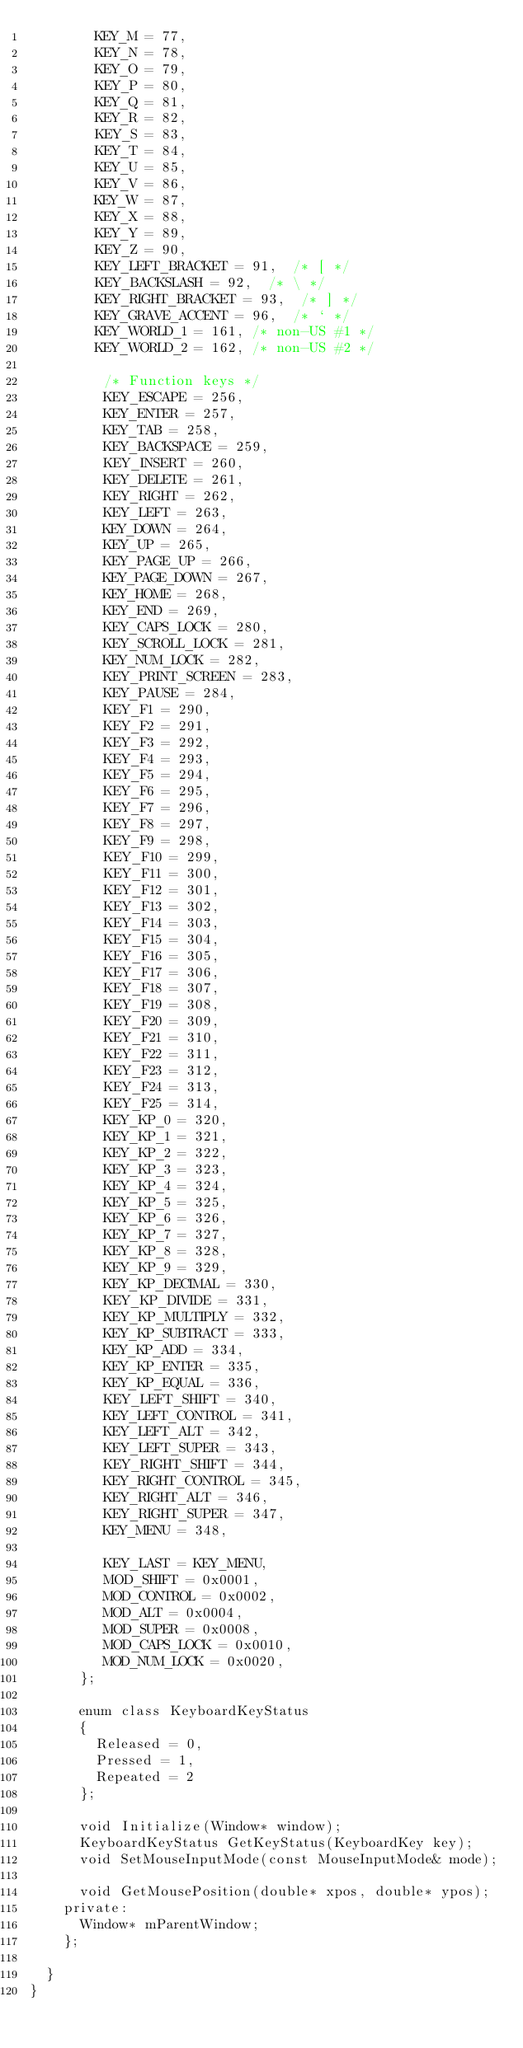<code> <loc_0><loc_0><loc_500><loc_500><_C_>				KEY_M = 77,
				KEY_N = 78,
				KEY_O = 79,
				KEY_P = 80,
				KEY_Q = 81,
				KEY_R = 82,
				KEY_S = 83,
				KEY_T = 84,
				KEY_U = 85,
				KEY_V = 86,
				KEY_W = 87,
				KEY_X = 88,
				KEY_Y = 89,
				KEY_Z = 90,
				KEY_LEFT_BRACKET = 91,  /* [ */
				KEY_BACKSLASH = 92,  /* \ */
				KEY_RIGHT_BRACKET = 93,  /* ] */
				KEY_GRAVE_ACCENT = 96,  /* ` */
				KEY_WORLD_1 = 161, /* non-US #1 */
				KEY_WORLD_2 = 162, /* non-US #2 */

			   /* Function keys */
			   KEY_ESCAPE = 256,
			   KEY_ENTER = 257,
			   KEY_TAB = 258,
			   KEY_BACKSPACE = 259,
			   KEY_INSERT = 260,
			   KEY_DELETE = 261,
			   KEY_RIGHT = 262,
			   KEY_LEFT = 263,
			   KEY_DOWN = 264,
			   KEY_UP = 265,
			   KEY_PAGE_UP = 266,
			   KEY_PAGE_DOWN = 267,
			   KEY_HOME = 268,
			   KEY_END = 269,
			   KEY_CAPS_LOCK = 280,
			   KEY_SCROLL_LOCK = 281,
			   KEY_NUM_LOCK = 282,
			   KEY_PRINT_SCREEN = 283,
			   KEY_PAUSE = 284,
			   KEY_F1 = 290,
			   KEY_F2 = 291,
			   KEY_F3 = 292,
			   KEY_F4 = 293,
			   KEY_F5 = 294,
			   KEY_F6 = 295,
			   KEY_F7 = 296,
			   KEY_F8 = 297,
			   KEY_F9 = 298,
			   KEY_F10 = 299,
			   KEY_F11 = 300,
			   KEY_F12 = 301,
			   KEY_F13 = 302,
			   KEY_F14 = 303,
			   KEY_F15 = 304,
			   KEY_F16 = 305,
			   KEY_F17 = 306,
			   KEY_F18 = 307,
			   KEY_F19 = 308,
			   KEY_F20 = 309,
			   KEY_F21 = 310,
			   KEY_F22 = 311,
			   KEY_F23 = 312,
			   KEY_F24 = 313,
			   KEY_F25 = 314,
			   KEY_KP_0 = 320,
			   KEY_KP_1 = 321,
			   KEY_KP_2 = 322,
			   KEY_KP_3 = 323,
			   KEY_KP_4 = 324,
			   KEY_KP_5 = 325,
			   KEY_KP_6 = 326,
			   KEY_KP_7 = 327,
			   KEY_KP_8 = 328,
			   KEY_KP_9 = 329,
			   KEY_KP_DECIMAL = 330,
			   KEY_KP_DIVIDE = 331,
			   KEY_KP_MULTIPLY = 332,
			   KEY_KP_SUBTRACT = 333,
			   KEY_KP_ADD = 334,
			   KEY_KP_ENTER = 335,
			   KEY_KP_EQUAL = 336,
			   KEY_LEFT_SHIFT = 340,
			   KEY_LEFT_CONTROL = 341,
			   KEY_LEFT_ALT = 342,
			   KEY_LEFT_SUPER = 343,
			   KEY_RIGHT_SHIFT = 344,
			   KEY_RIGHT_CONTROL = 345,
			   KEY_RIGHT_ALT = 346,
			   KEY_RIGHT_SUPER = 347,
			   KEY_MENU = 348,

			   KEY_LAST = KEY_MENU,
			   MOD_SHIFT = 0x0001,
			   MOD_CONTROL = 0x0002,
			   MOD_ALT = 0x0004,
			   MOD_SUPER = 0x0008,
			   MOD_CAPS_LOCK = 0x0010,
			   MOD_NUM_LOCK = 0x0020,
			};

			enum class KeyboardKeyStatus
			{
				Released = 0,
				Pressed = 1,
				Repeated = 2
			};

			void Initialize(Window* window);
			KeyboardKeyStatus GetKeyStatus(KeyboardKey key);
			void SetMouseInputMode(const MouseInputMode& mode);

			void GetMousePosition(double* xpos, double* ypos);
		private:
			Window* mParentWindow;
		};

	}
}</code> 